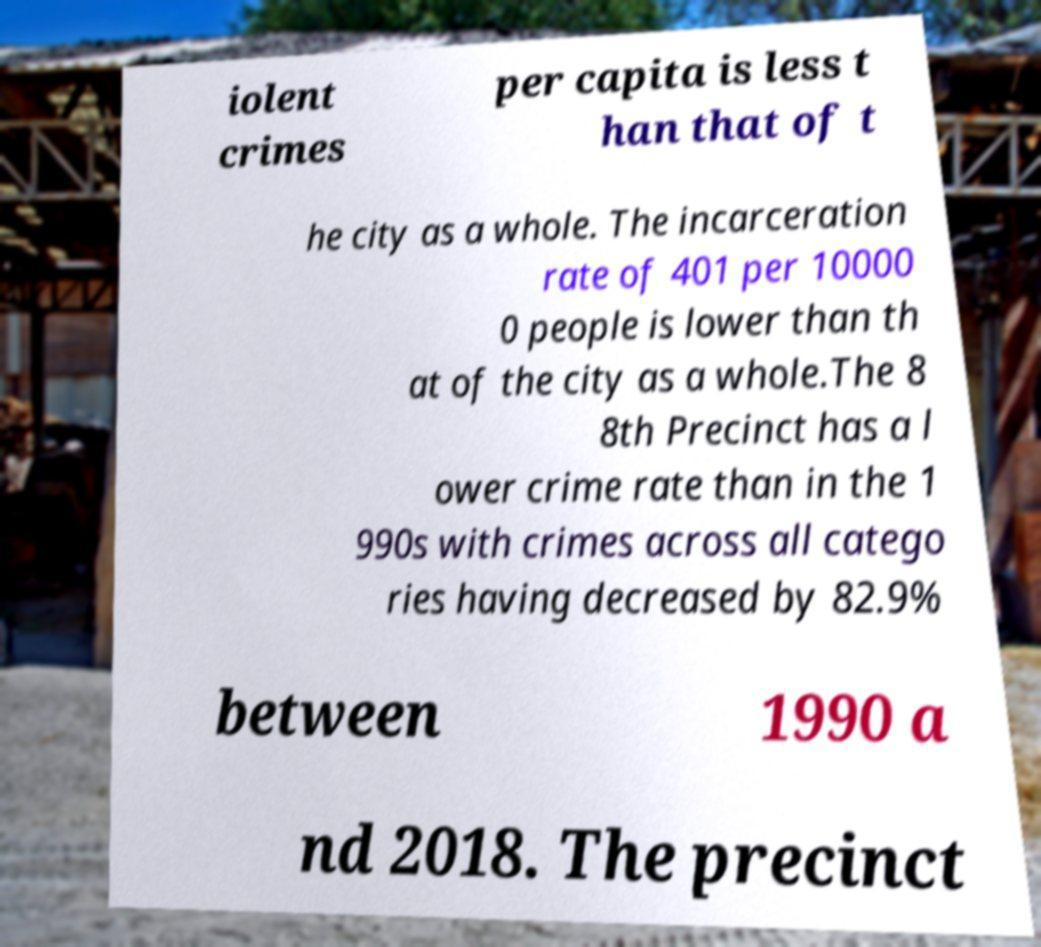There's text embedded in this image that I need extracted. Can you transcribe it verbatim? iolent crimes per capita is less t han that of t he city as a whole. The incarceration rate of 401 per 10000 0 people is lower than th at of the city as a whole.The 8 8th Precinct has a l ower crime rate than in the 1 990s with crimes across all catego ries having decreased by 82.9% between 1990 a nd 2018. The precinct 